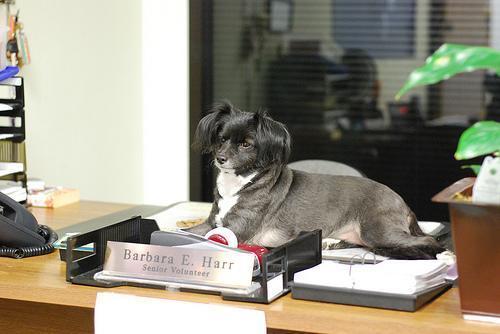How many dogs are visible?
Give a very brief answer. 1. 